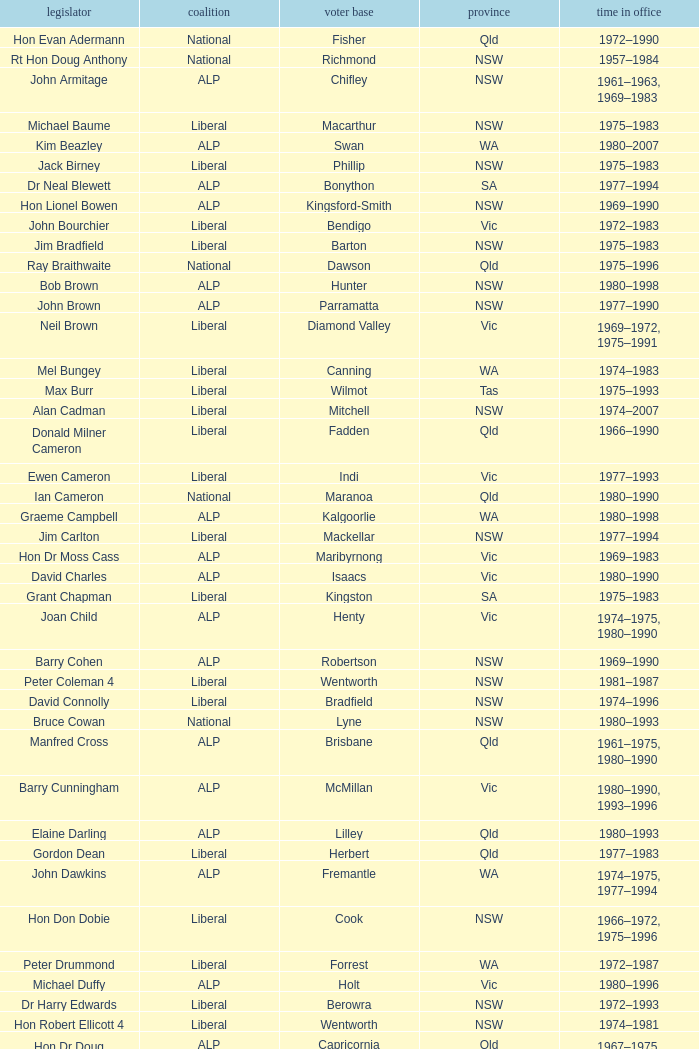When was Hon Les Johnson in office? 1955–1966, 1969–1984. 